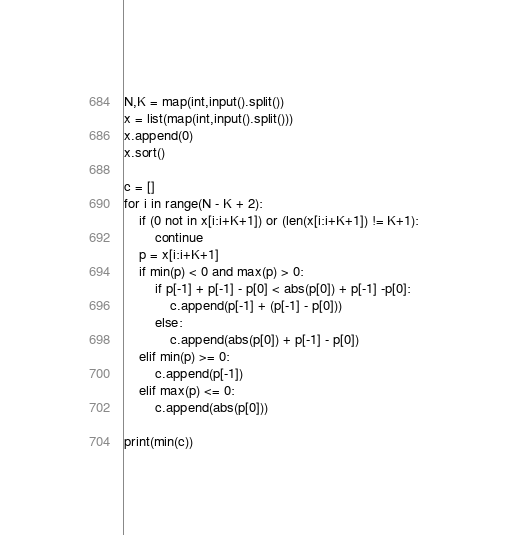<code> <loc_0><loc_0><loc_500><loc_500><_Python_>N,K = map(int,input().split())
x = list(map(int,input().split()))
x.append(0)
x.sort()

c = []
for i in range(N - K + 2):
    if (0 not in x[i:i+K+1]) or (len(x[i:i+K+1]) != K+1):
        continue
    p = x[i:i+K+1]
    if min(p) < 0 and max(p) > 0:
        if p[-1] + p[-1] - p[0] < abs(p[0]) + p[-1] -p[0]:
            c.append(p[-1] + (p[-1] - p[0]))
        else:
            c.append(abs(p[0]) + p[-1] - p[0])
    elif min(p) >= 0:
        c.append(p[-1])
    elif max(p) <= 0:
        c.append(abs(p[0]))

print(min(c))
</code> 